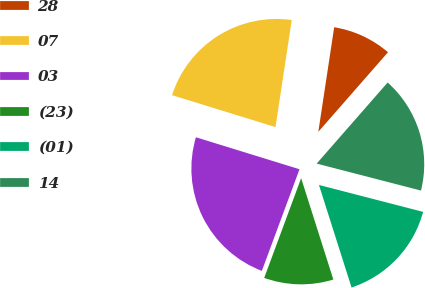Convert chart to OTSL. <chart><loc_0><loc_0><loc_500><loc_500><pie_chart><fcel>28<fcel>07<fcel>03<fcel>(23)<fcel>(01)<fcel>14<nl><fcel>9.05%<fcel>22.63%<fcel>24.12%<fcel>10.54%<fcel>16.08%<fcel>17.58%<nl></chart> 